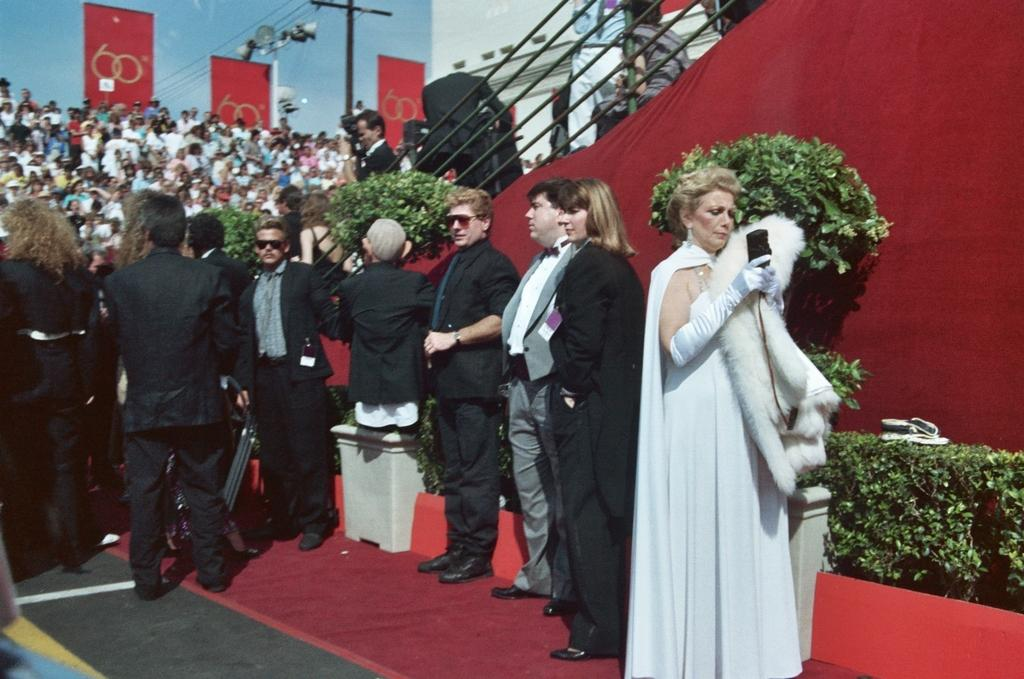What can be seen in the image involving people? There are people standing in the image. What is the pole with cables used for in the image? The pole with cables is not explicitly explained in the image, but it could be related to power lines or communication infrastructure. What is visible in the background of the image? The sky is visible in the image. What type of vegetation is present in the image? There are plants in the image. Where is the key located in the image? There is no key present in the image. What type of equipment does the fireman use in the image? There is no fireman or related equipment present in the image. 